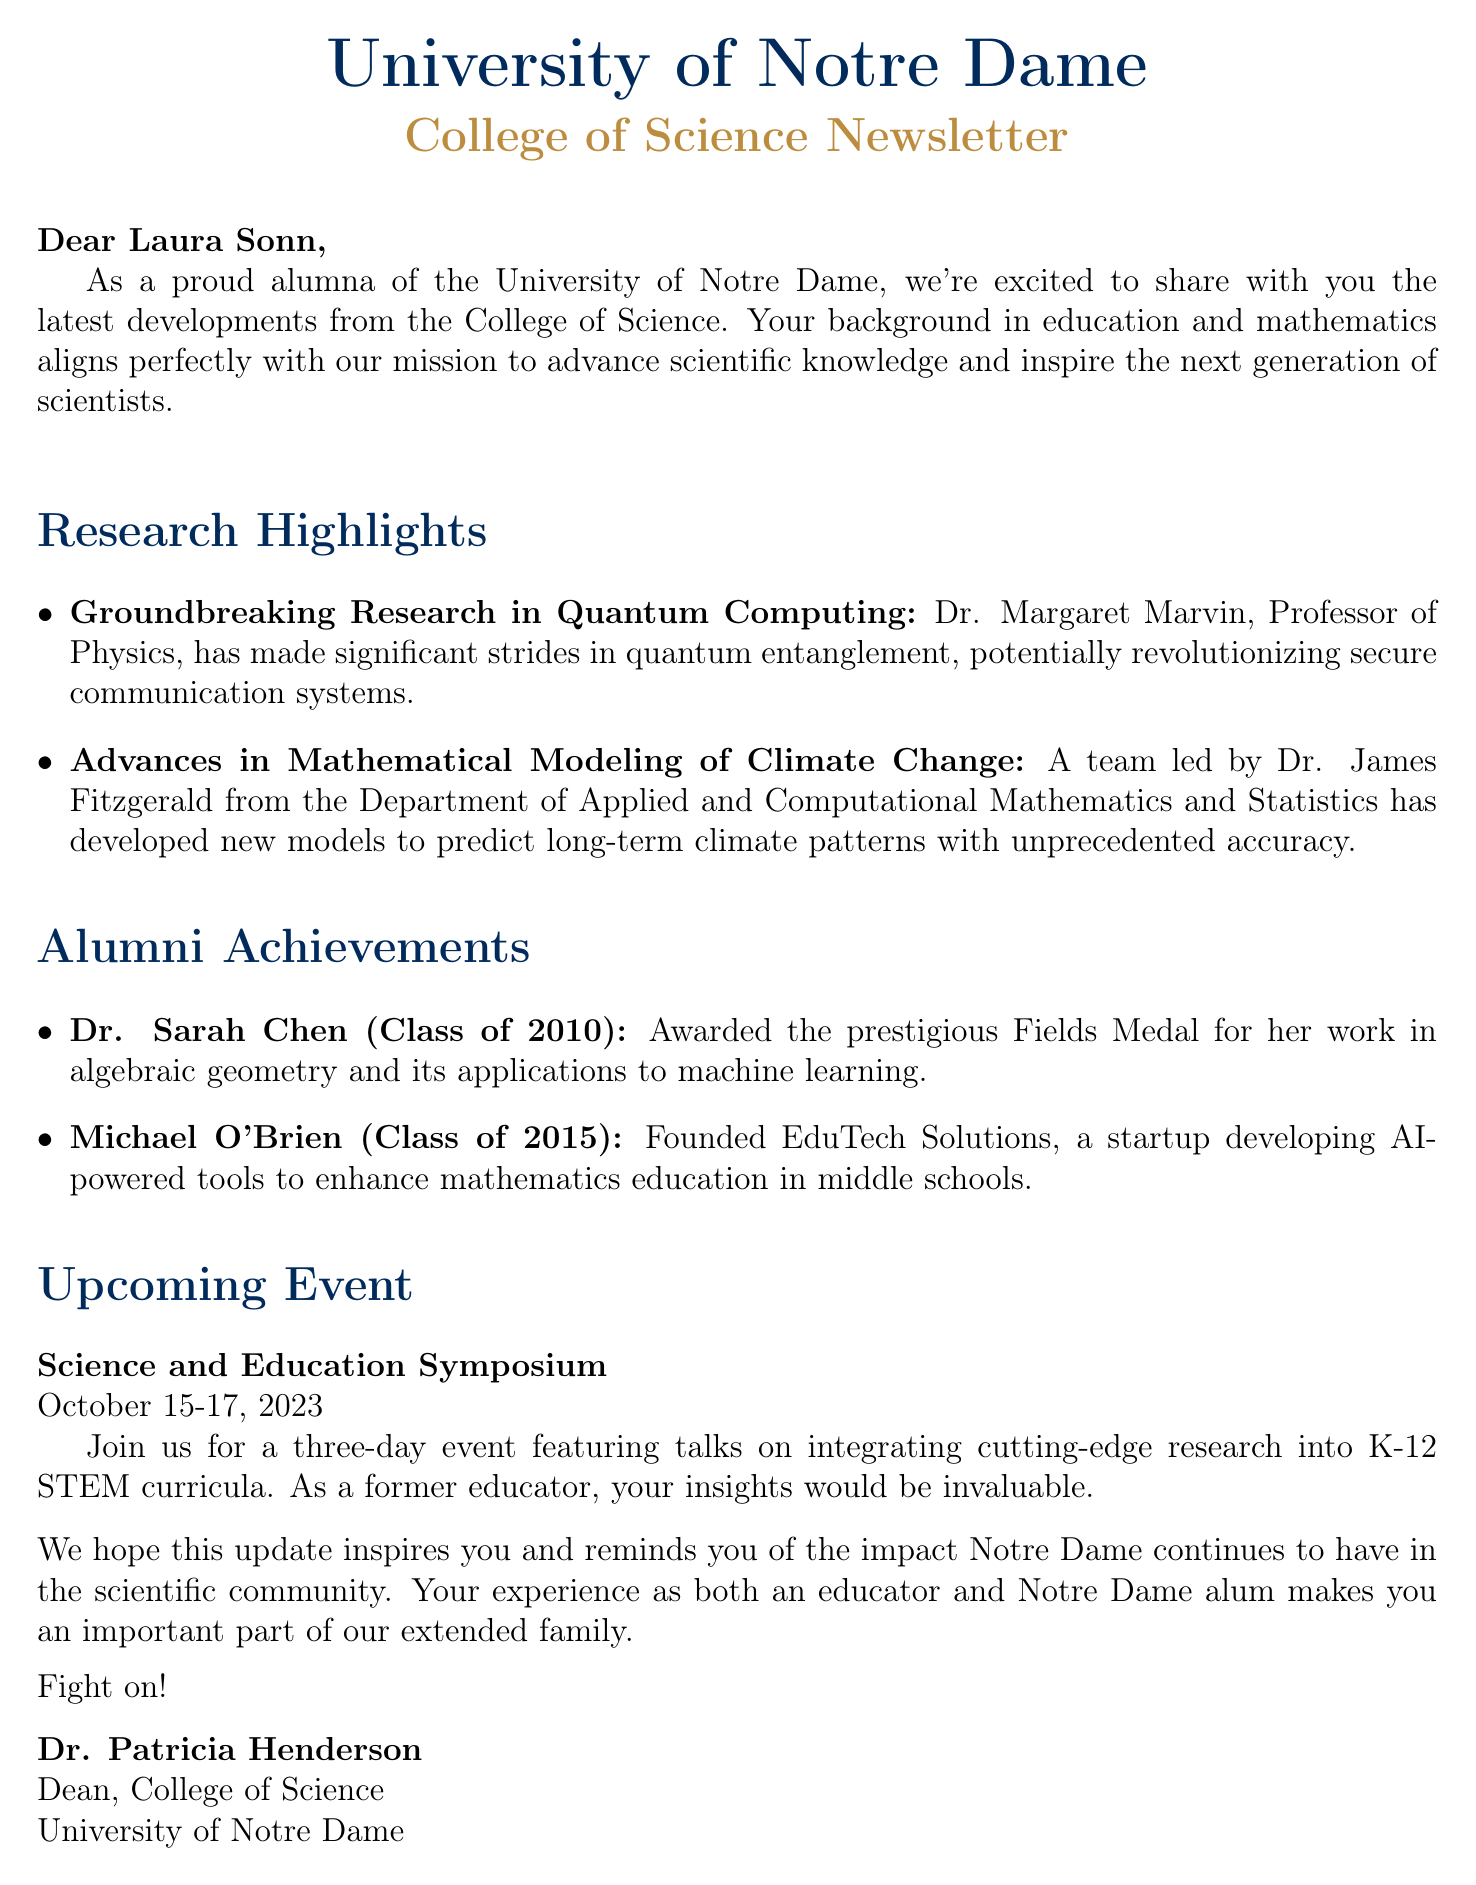What is the subject of the email? The subject is the title of the email that summarizes its main content.
Answer: University of Notre Dame College of Science: Breakthroughs and Alumni Spotlight Who is the Dean of the College of Science? The Dean is the person who signed the email and is in charge of the College of Science.
Answer: Dr. Patricia Henderson What recent achievement did Dr. Sarah Chen receive? This achievement is specifically mentioned under alumni achievements.
Answer: Fields Medal What is the date of the upcoming Science and Education Symposium? This date can be found in the section describing the event.
Answer: October 15-17, 2023 Which research area does Dr. Margaret Marvin specialize in? The area of study is mentioned alongside her groundbreaking research.
Answer: Quantum Computing How many alumni achievements are highlighted in the newsletter? This number is determined by counting the listed achievements in the document.
Answer: Two What kind of tools did Michael O'Brien's startup develop? This information describes the focus of Michael O'Brien's startup achievement.
Answer: AI-powered tools What is one of the research highlights mentioned in the newsletter? This question asks for the title of a highlight from the research section.
Answer: Groundbreaking Research in Quantum Computing What is the purpose of the Science and Education Symposium? The purpose is described in the event section, focusing on research and education integration.
Answer: Integrating cutting-edge research into K-12 STEM curricula 